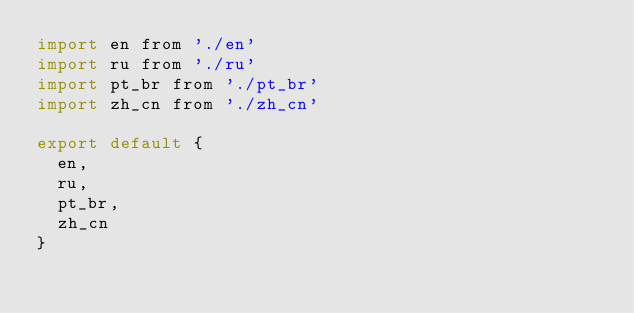<code> <loc_0><loc_0><loc_500><loc_500><_JavaScript_>import en from './en'
import ru from './ru'
import pt_br from './pt_br'
import zh_cn from './zh_cn'

export default {
  en,
  ru,
  pt_br,
  zh_cn
}
</code> 